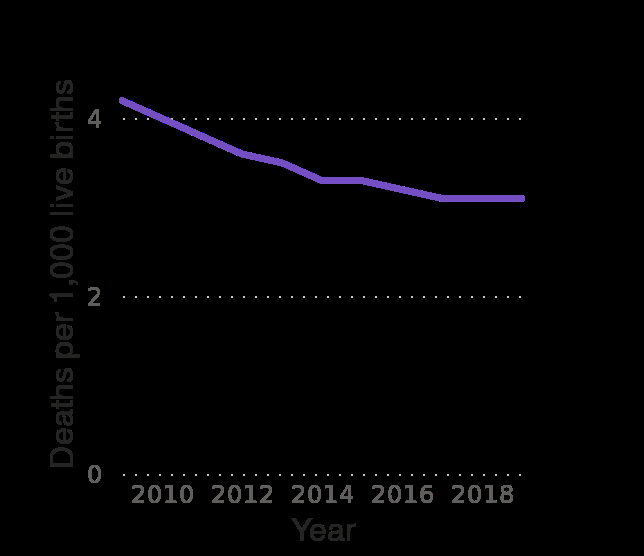<image>
What is being measured on the y-axis of the area plot? The y-axis measures Deaths per 1,000 live births. How has infant mortality in Australia changed over the years?  Infant mortality in Australia has decreased, with its lowest recorded year in 2018. 